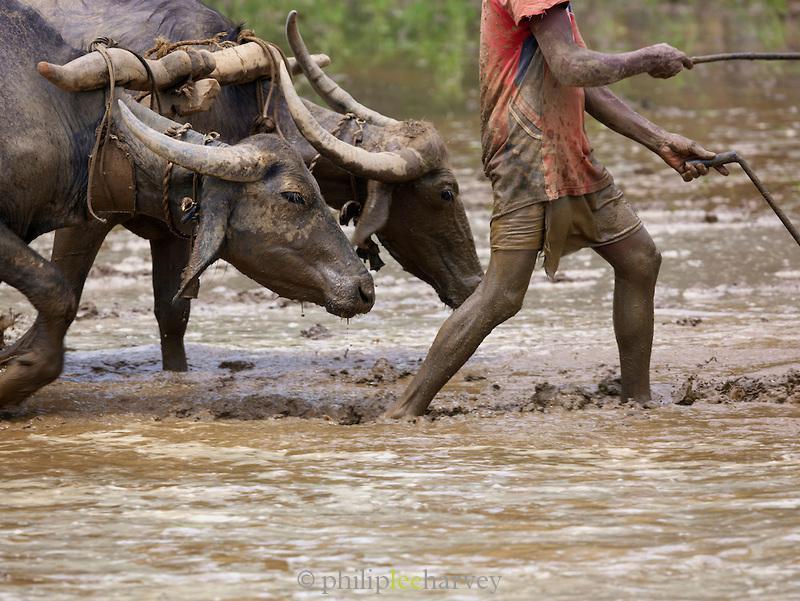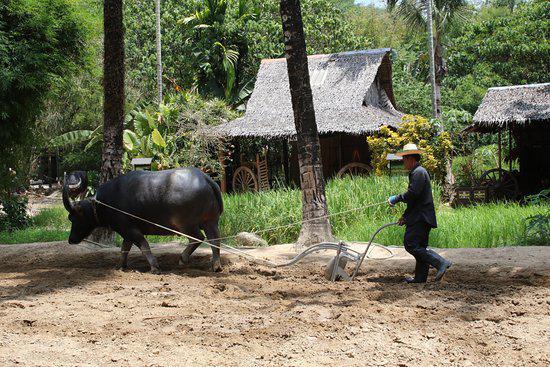The first image is the image on the left, the second image is the image on the right. Considering the images on both sides, is "There are two horned ox pulling a til held by a man with a white long sleeve shirt and ball cap." valid? Answer yes or no. No. 